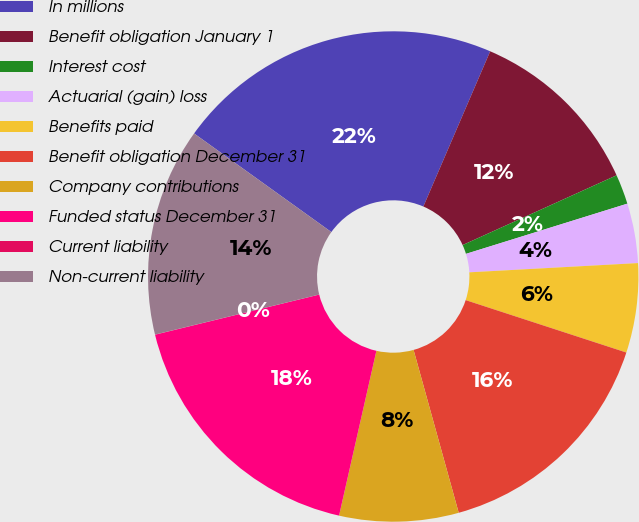Convert chart to OTSL. <chart><loc_0><loc_0><loc_500><loc_500><pie_chart><fcel>In millions<fcel>Benefit obligation January 1<fcel>Interest cost<fcel>Actuarial (gain) loss<fcel>Benefits paid<fcel>Benefit obligation December 31<fcel>Company contributions<fcel>Funded status December 31<fcel>Current liability<fcel>Non-current liability<nl><fcel>21.56%<fcel>11.76%<fcel>1.97%<fcel>3.93%<fcel>5.89%<fcel>15.68%<fcel>7.85%<fcel>17.64%<fcel>0.01%<fcel>13.72%<nl></chart> 